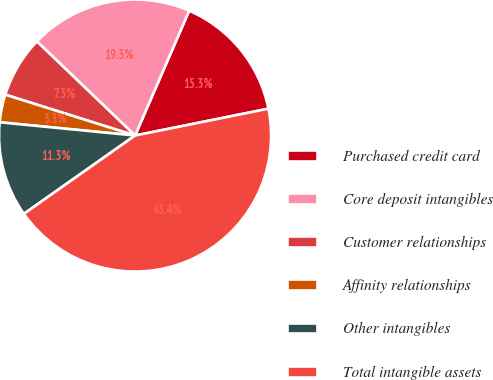Convert chart to OTSL. <chart><loc_0><loc_0><loc_500><loc_500><pie_chart><fcel>Purchased credit card<fcel>Core deposit intangibles<fcel>Customer relationships<fcel>Affinity relationships<fcel>Other intangibles<fcel>Total intangible assets<nl><fcel>15.33%<fcel>19.34%<fcel>7.31%<fcel>3.3%<fcel>11.32%<fcel>43.39%<nl></chart> 